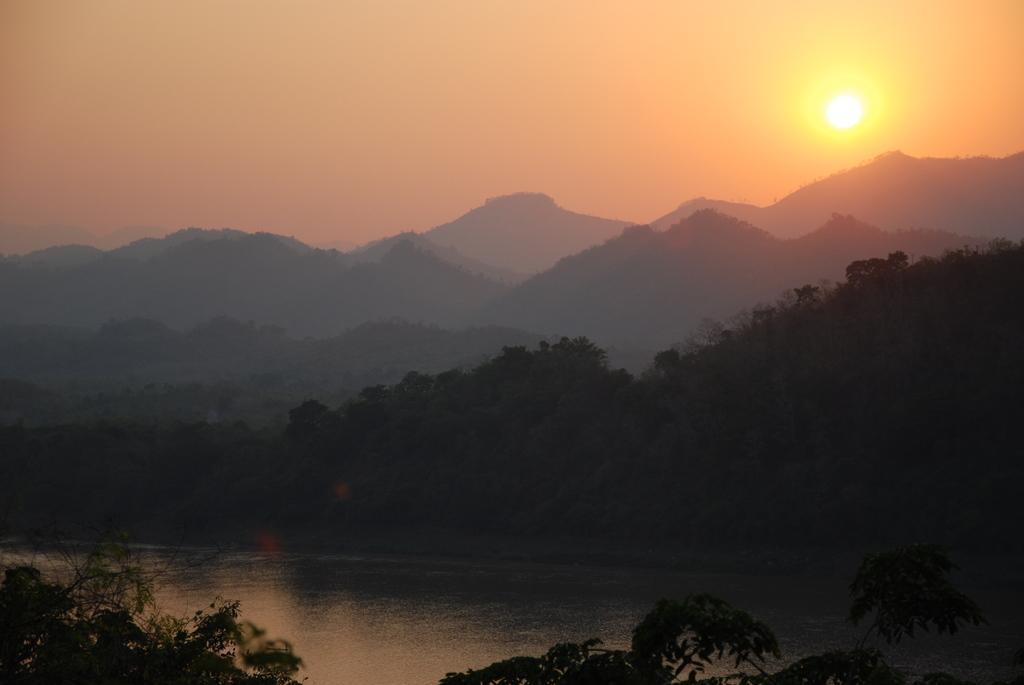How would you summarize this image in a sentence or two? At the bottom of the picture, we see the trees. We see water and this water might be in the pond. There are trees and hills in the background. At the top, we see the sky and the sun. 